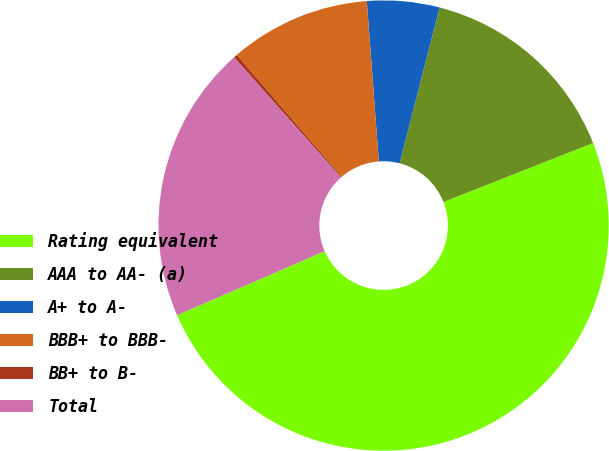<chart> <loc_0><loc_0><loc_500><loc_500><pie_chart><fcel>Rating equivalent<fcel>AAA to AA- (a)<fcel>A+ to A-<fcel>BBB+ to BBB-<fcel>BB+ to B-<fcel>Total<nl><fcel>49.46%<fcel>15.03%<fcel>5.19%<fcel>10.11%<fcel>0.27%<fcel>19.95%<nl></chart> 